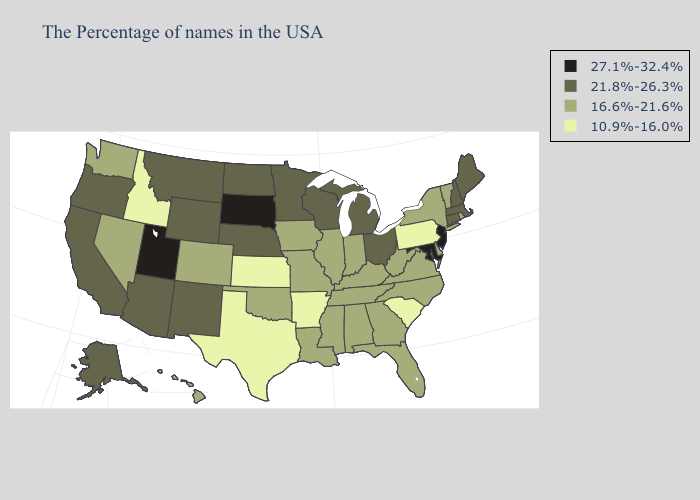Name the states that have a value in the range 10.9%-16.0%?
Answer briefly. Pennsylvania, South Carolina, Arkansas, Kansas, Texas, Idaho. Which states have the highest value in the USA?
Concise answer only. New Jersey, Maryland, South Dakota, Utah. Name the states that have a value in the range 27.1%-32.4%?
Keep it brief. New Jersey, Maryland, South Dakota, Utah. Name the states that have a value in the range 21.8%-26.3%?
Be succinct. Maine, Massachusetts, New Hampshire, Connecticut, Ohio, Michigan, Wisconsin, Minnesota, Nebraska, North Dakota, Wyoming, New Mexico, Montana, Arizona, California, Oregon, Alaska. Does Michigan have a lower value than South Dakota?
Concise answer only. Yes. Name the states that have a value in the range 27.1%-32.4%?
Keep it brief. New Jersey, Maryland, South Dakota, Utah. Name the states that have a value in the range 21.8%-26.3%?
Keep it brief. Maine, Massachusetts, New Hampshire, Connecticut, Ohio, Michigan, Wisconsin, Minnesota, Nebraska, North Dakota, Wyoming, New Mexico, Montana, Arizona, California, Oregon, Alaska. What is the lowest value in states that border South Carolina?
Give a very brief answer. 16.6%-21.6%. Does Kentucky have the lowest value in the USA?
Write a very short answer. No. Name the states that have a value in the range 16.6%-21.6%?
Keep it brief. Rhode Island, Vermont, New York, Delaware, Virginia, North Carolina, West Virginia, Florida, Georgia, Kentucky, Indiana, Alabama, Tennessee, Illinois, Mississippi, Louisiana, Missouri, Iowa, Oklahoma, Colorado, Nevada, Washington, Hawaii. Does the map have missing data?
Short answer required. No. What is the value of Delaware?
Short answer required. 16.6%-21.6%. Name the states that have a value in the range 21.8%-26.3%?
Keep it brief. Maine, Massachusetts, New Hampshire, Connecticut, Ohio, Michigan, Wisconsin, Minnesota, Nebraska, North Dakota, Wyoming, New Mexico, Montana, Arizona, California, Oregon, Alaska. What is the lowest value in states that border Oklahoma?
Short answer required. 10.9%-16.0%. Name the states that have a value in the range 21.8%-26.3%?
Answer briefly. Maine, Massachusetts, New Hampshire, Connecticut, Ohio, Michigan, Wisconsin, Minnesota, Nebraska, North Dakota, Wyoming, New Mexico, Montana, Arizona, California, Oregon, Alaska. 